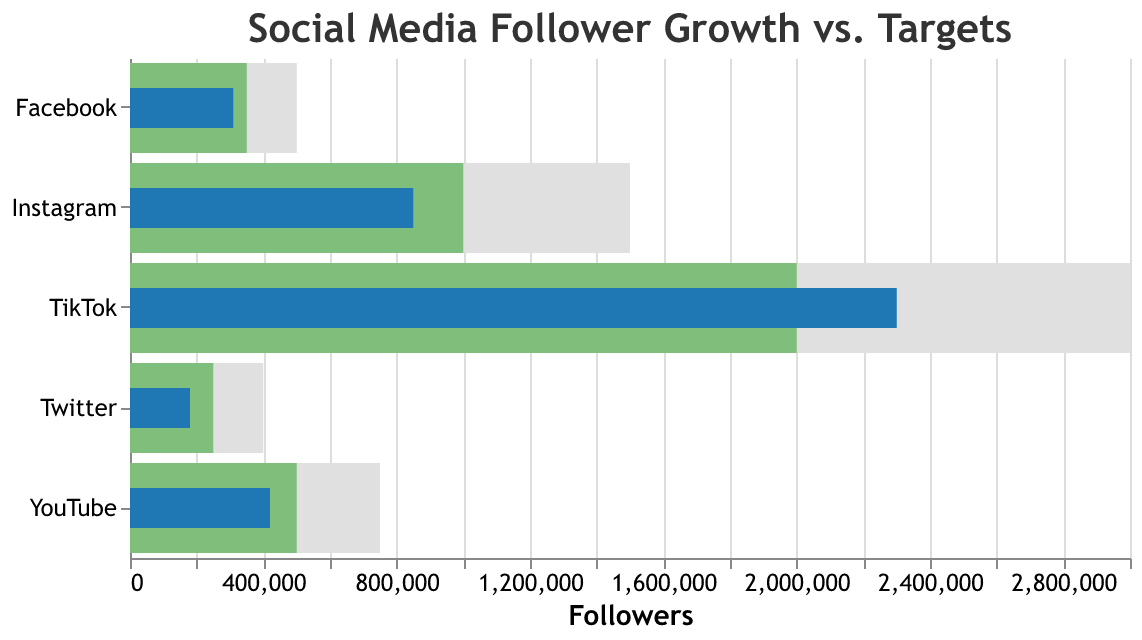What's the title of the figure? The title of the figure is given at the top of the chart.
Answer: Social Media Follower Growth vs. Targets Which platform has the highest actual follower count? By looking at the blue bars (Actual counts), we can see the highest one.
Answer: TikTok How many platforms have actual follower counts below their targets? Compare blue bars (Actual counts) to green bars (Targets) for each platform.
Answer: 4 What's the difference between the maximum and actual count for Facebook? Subtract the actual count (310,000) from the maximum count (500,000) for Facebook. 500,000 - 310,000 = 190,000
Answer: 190,000 Which platform has surpassed its target, and by how much? Look for platforms where the blue bar (Actual count) is longer than the green bar (Target count) and calculate the difference.
Answer: TikTok by 300,000 If we sum the actual follower counts of Instagram, YouTube, and Twitter, what do we get? Add the actual counts: 850,000 (Instagram) + 420,000 (YouTube) + 180,000 (Twitter). 850,000 + 420,000 + 180,000 = 1,450,000
Answer: 1,450,000 Which platform has the smallest gap between its target and actual follower count? Calculate the difference between target and actual counts for each platform and find the smallest one.
Answer: Facebook (40,000) How does the actual count for Instagram compare to its maximum count? Compare the actual count (850,000) to the maximum count (1,500,000).
Answer: Less than Is any platform more than halfway to its maximum count? If yes, which one(s)? For each platform, check if the actual count is greater than half of the maximum count.
Answer: TikTok, YouTube 